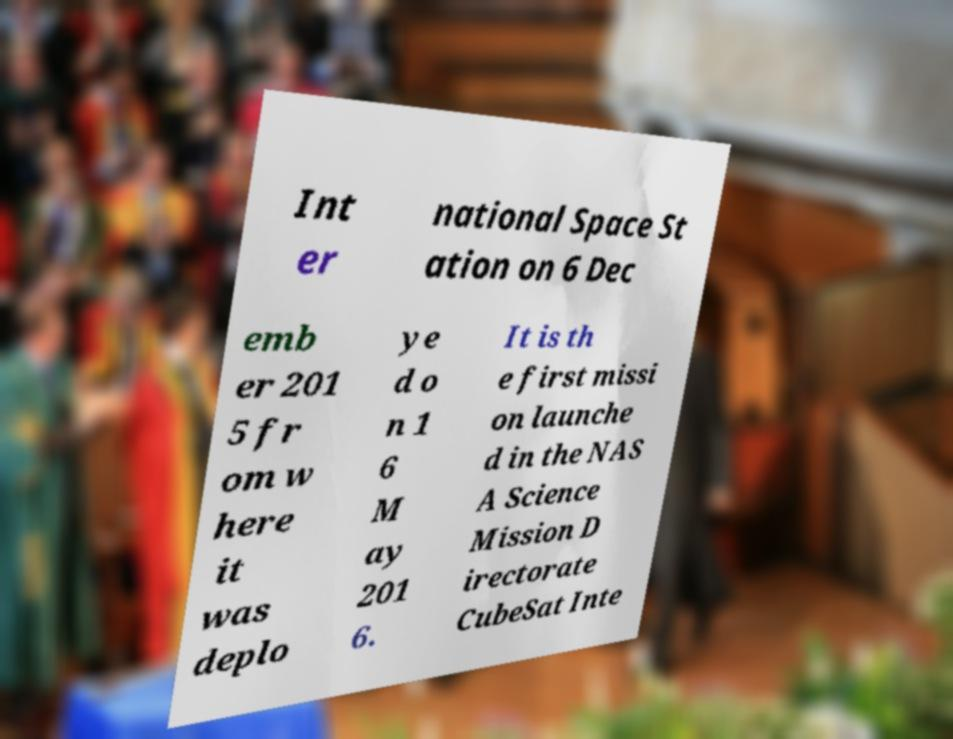There's text embedded in this image that I need extracted. Can you transcribe it verbatim? Int er national Space St ation on 6 Dec emb er 201 5 fr om w here it was deplo ye d o n 1 6 M ay 201 6. It is th e first missi on launche d in the NAS A Science Mission D irectorate CubeSat Inte 